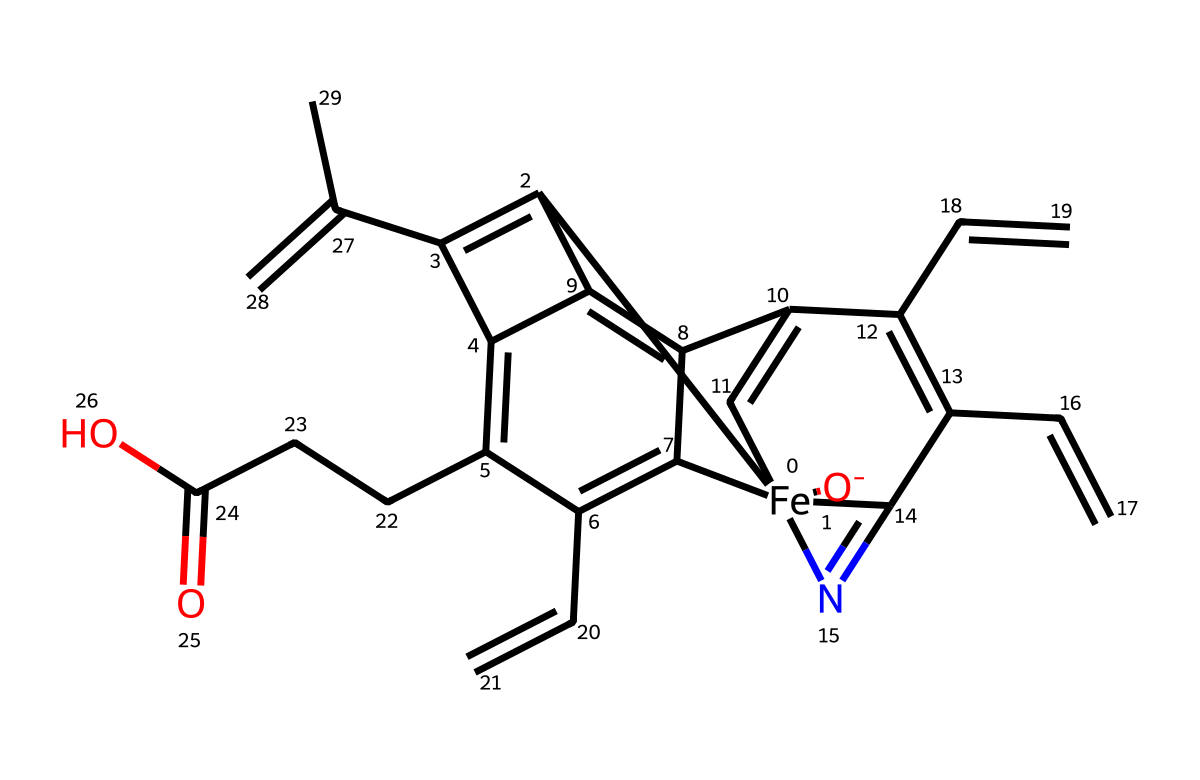What is the central metal atom in this coordination compound? The central metal atom in hemoglobin is iron, represented by the [Fe] in the SMILES notation.
Answer: iron How many nitrogen atoms are present in the chemical structure? The SMILES structure indicates there are 4 nitrogen atoms, which can be counted by identifying the 'N' symbols.
Answer: 4 What type of bonding is primarily responsible for the coordination in hemoglobin? The coordination in hemoglobin is primarily due to dative or coordinate covalent bonding, where the metal ion (iron) shares its d orbitals with the nitrogen atoms on the heme group.
Answer: coordinate covalent bonding What is the oxidation state of iron in this hemoglobin structure? The oxidation state of iron in hemoglobin, as indicated in the structure and the attached ligands, is typically +2 (ferrous state).
Answer: +2 What functional group is represented by "O-CCC(=O)O" in the structure? The functional group "O-CCC(=O)O" includes a carboxylic acid group (-COOH) and suggests the presence of a side chain in the heme structure.
Answer: carboxylic acid Which molecular feature allows hemoglobin to bind oxygen? The presence of the iron(II) ion in the heme group allows hemoglobin to form a reversible bond with oxygen molecules through coordination.
Answer: iron(II) ion 